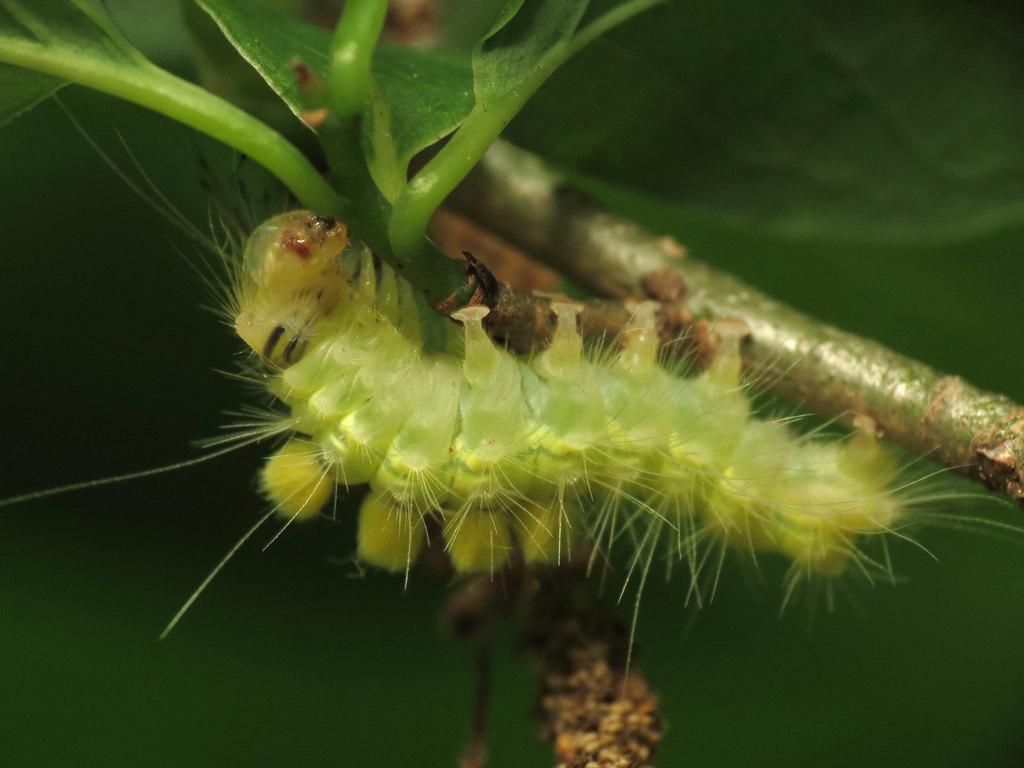Please provide a concise description of this image. In the foreground of this image, there is an insect on the stem. At the top, there are leaves and there is a green background. 